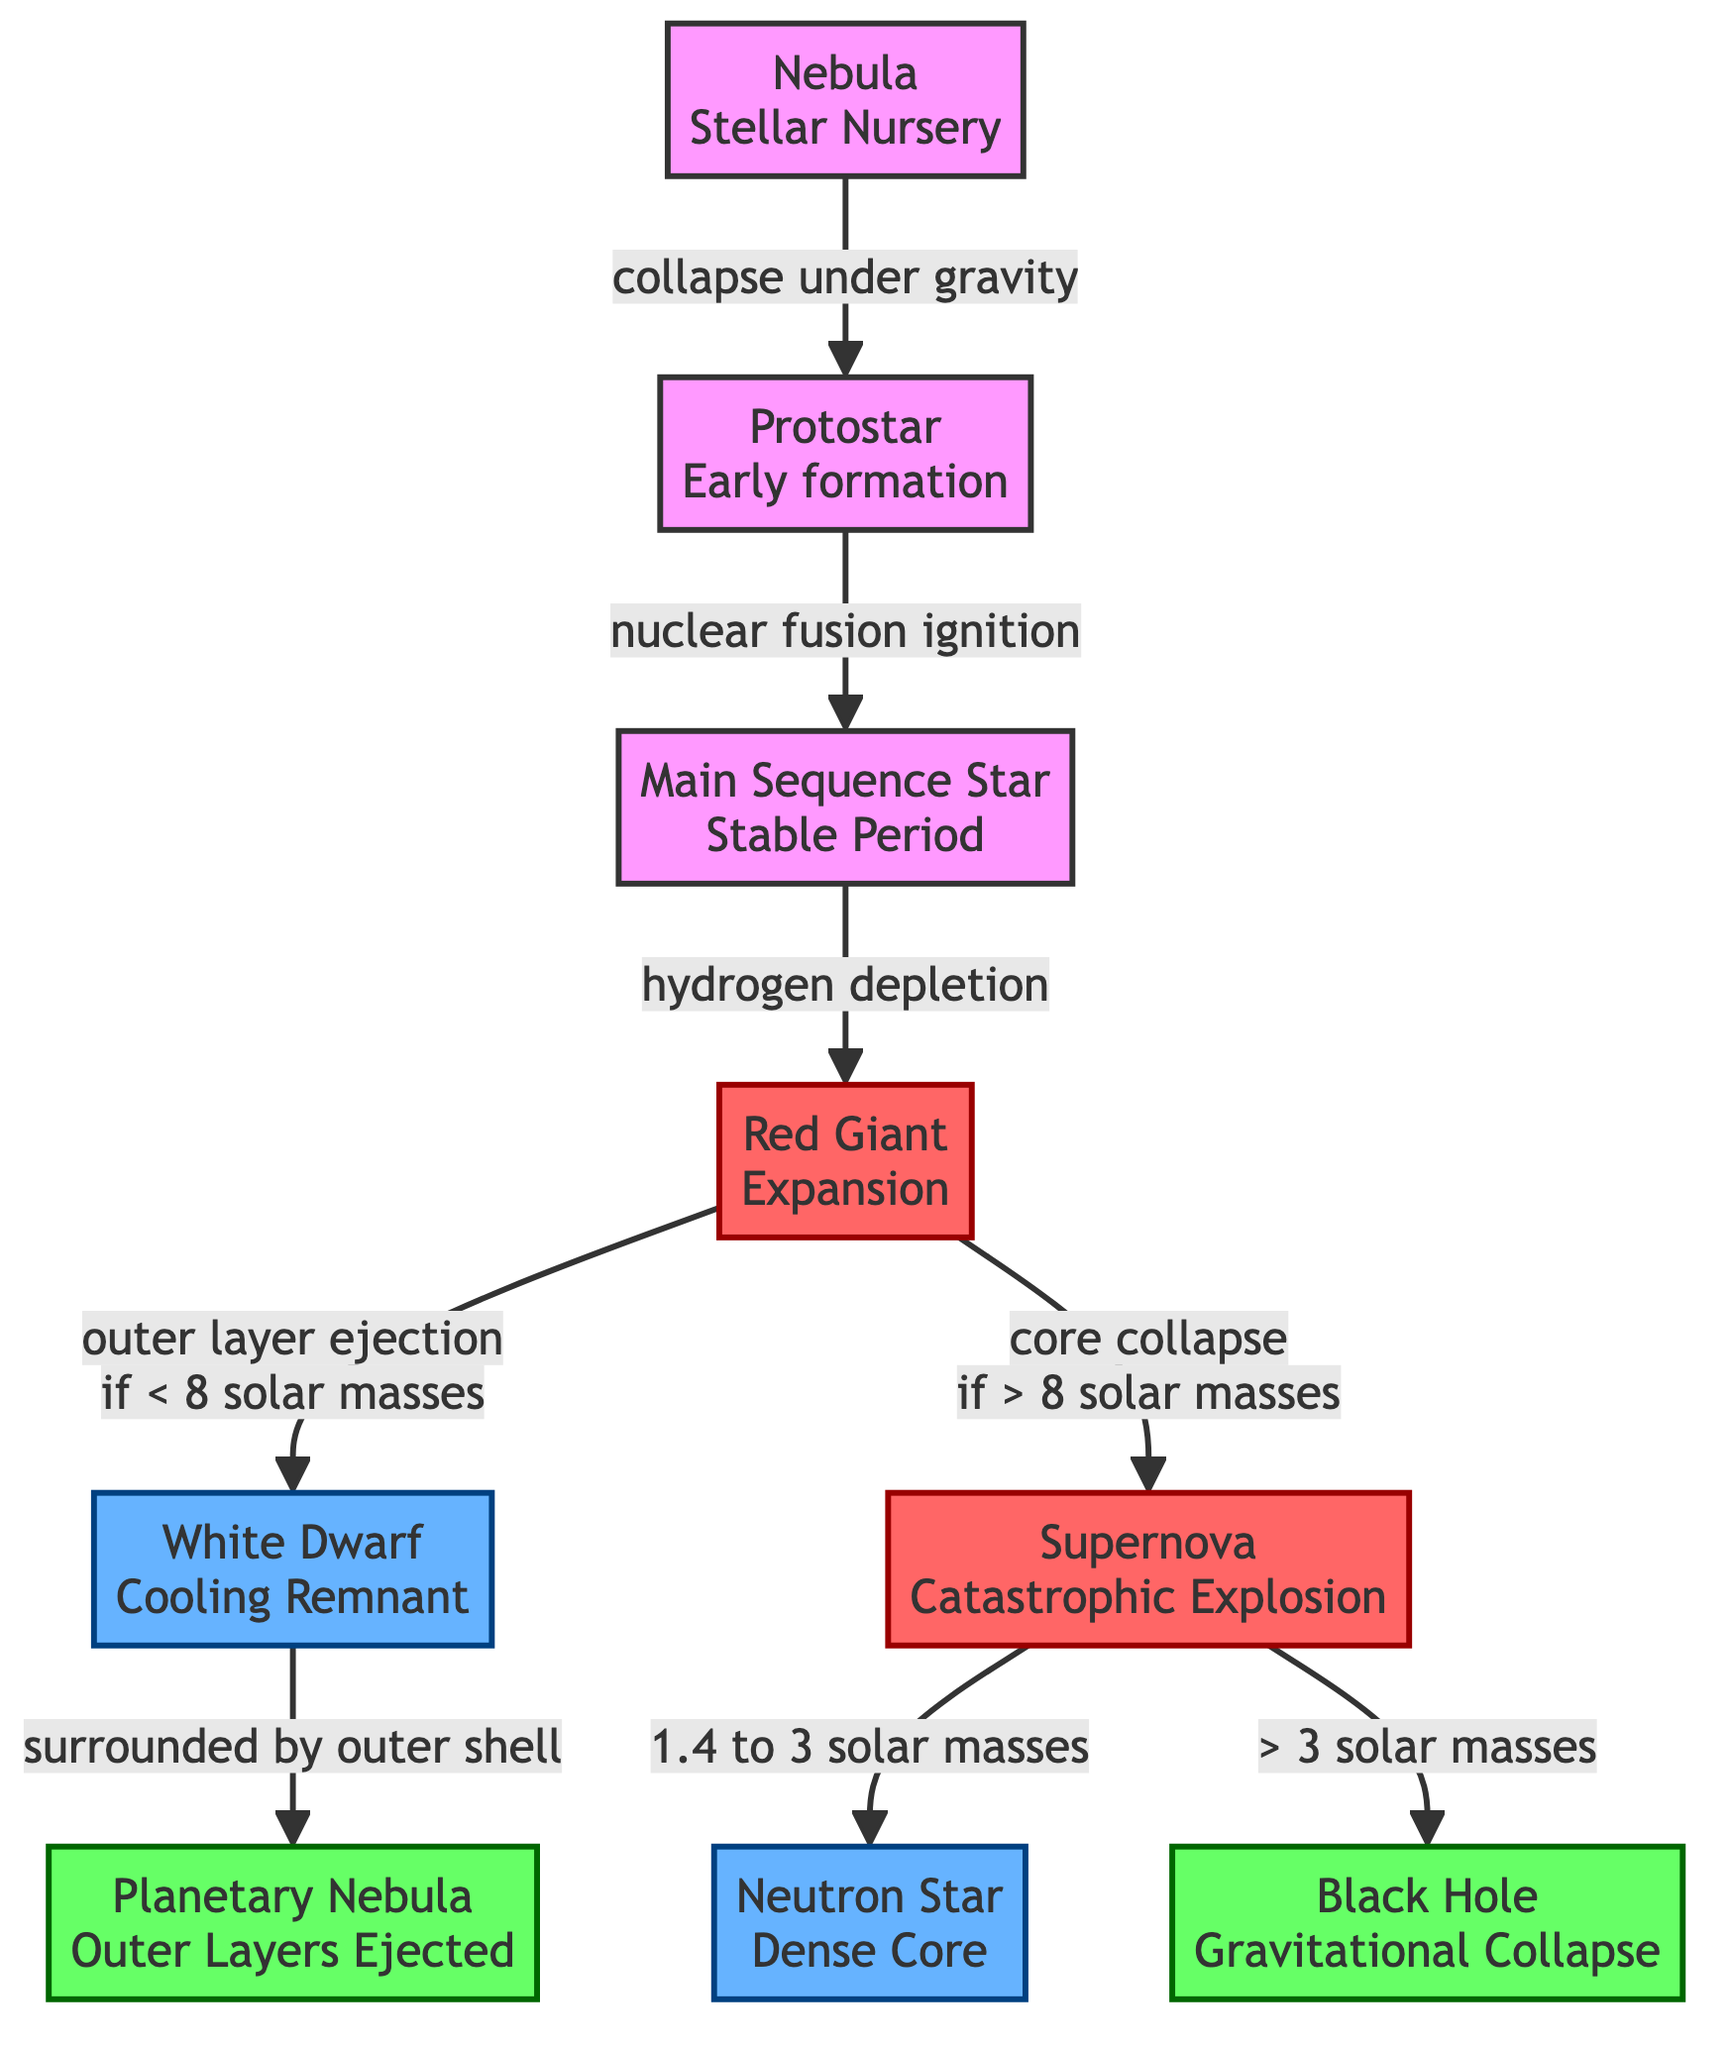What is the first stage of a star's lifecycle? The diagram starts with the "Nebula" as the initial stage, from which a star begins to form by collapsing under gravity.
Answer: Nebula What follows the protostar in the star's lifecycle? After the "Protostar" stage, the next stage is the "Main Sequence Star," which indicates that nuclear fusion has ignited.
Answer: Main Sequence Star How many stages are there in total in this star lifecycle diagram? The diagram displays a total of 8 stages, as identified in the flowchart: Nebula, Protostar, Main Sequence Star, Red Giant, Supernova, White Dwarf, Neutron Star, Black Hole, and Planetary Nebula.
Answer: 8 Which stage leads to a neutron star if the original star's mass was between 1.4 to 3 solar masses? The "Supernova" stage is where a supernova event occurs, and if the original star's mass falls within that range after its core collapses, it results in a neutron star.
Answer: Supernova What happens to a red giant with a mass less than 8 solar masses? According to the diagram, a red giant with a mass less than 8 solar masses will eject its outer layers, leading to the formation of a "White Dwarf."
Answer: White Dwarf What is formed after a supernova if the original star has more than 3 solar masses? If the original star has more than 3 solar masses, the outcome of the supernova will lead to the formation of a "Black Hole."
Answer: Black Hole Which two end stages are related to white dwarfs in the diagram? The two stages related to white dwarfs are the "Planetary Nebula" where the outer layers are ejected, leaving the white dwarf surrounded by debris, and the "White Dwarf" itself.
Answer: Planetary Nebula, White Dwarf What process transitions a nebula into a protostar? The transition from a "Nebula" to a "Protostar" occurs through the process of gravitational collapse, where the gas and dust come together under their own gravity.
Answer: Collapse under gravity 